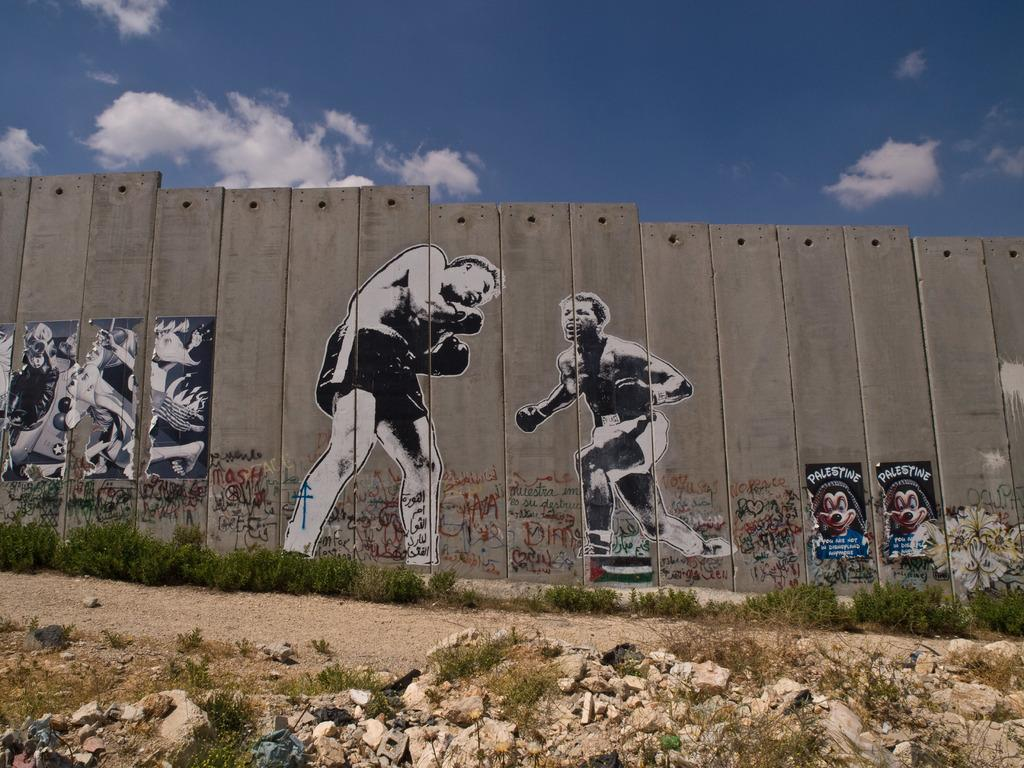What type of structure is visible in the image? There is a wooden boundary wall in the image. What is depicted on the wall? The wall has two kickboxer paintings on it. What can be seen on the ground in front of the wall? There are rocks on the ground in front of the wall. What is visible in the background of the image? The sky is visible in the image, and clouds are present in the sky. How many geese are participating in the competition depicted on the wall? There is no competition depicted on the wall, only two kickboxer paintings. How much dust can be seen on the rocks in front of the wall? The image does not provide information about the presence of dust on the rocks; it only shows rocks on the ground. 